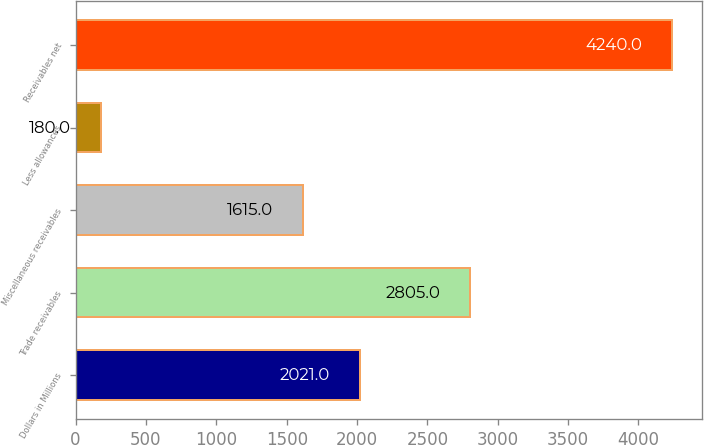Convert chart to OTSL. <chart><loc_0><loc_0><loc_500><loc_500><bar_chart><fcel>Dollars in Millions<fcel>Trade receivables<fcel>Miscellaneous receivables<fcel>Less allowances<fcel>Receivables net<nl><fcel>2021<fcel>2805<fcel>1615<fcel>180<fcel>4240<nl></chart> 